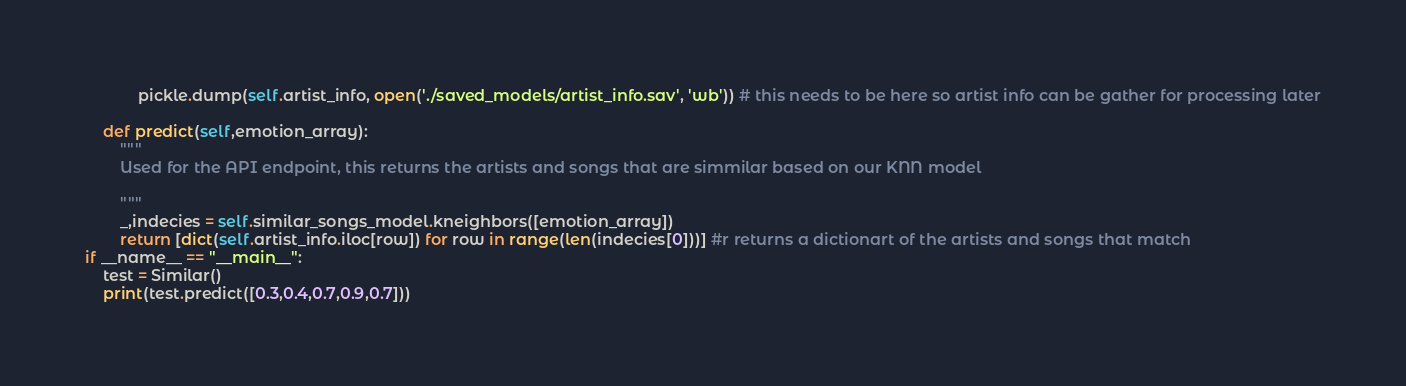<code> <loc_0><loc_0><loc_500><loc_500><_Python_>            pickle.dump(self.artist_info, open('./saved_models/artist_info.sav', 'wb')) # this needs to be here so artist info can be gather for processing later
            
    def predict(self,emotion_array):
        """
        Used for the API endpoint, this returns the artists and songs that are simmilar based on our KNN model
        
        """
        _,indecies = self.similar_songs_model.kneighbors([emotion_array])
        return [dict(self.artist_info.iloc[row]) for row in range(len(indecies[0]))] #r returns a dictionart of the artists and songs that match 
if __name__ == "__main__":
    test = Similar()
    print(test.predict([0.3,0.4,0.7,0.9,0.7]))</code> 